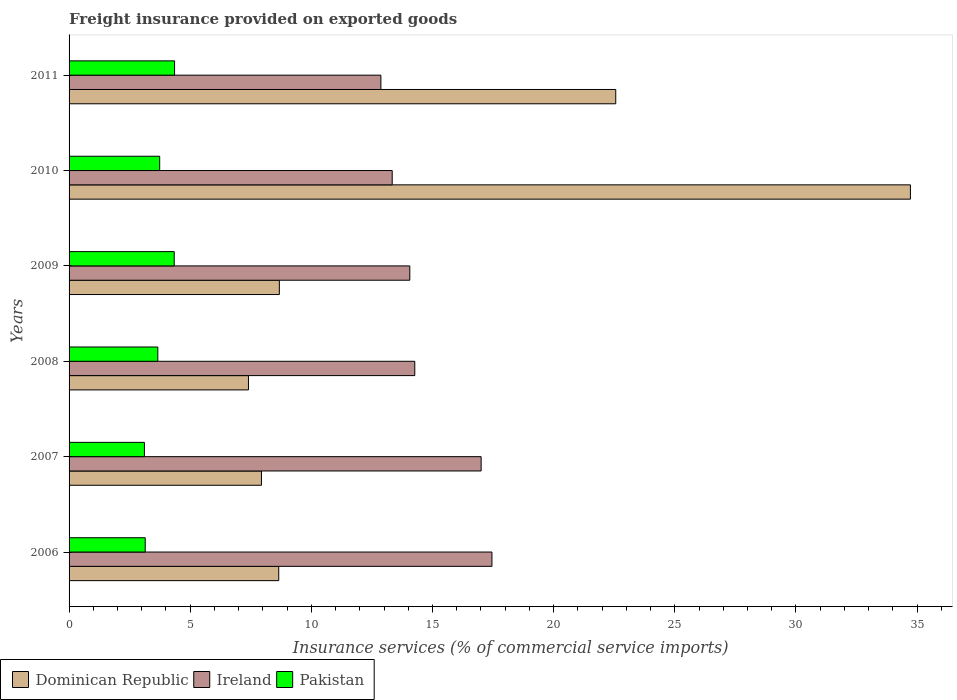How many bars are there on the 6th tick from the top?
Ensure brevity in your answer.  3. What is the label of the 5th group of bars from the top?
Ensure brevity in your answer.  2007. In how many cases, is the number of bars for a given year not equal to the number of legend labels?
Offer a very short reply. 0. What is the freight insurance provided on exported goods in Pakistan in 2006?
Offer a terse response. 3.14. Across all years, what is the maximum freight insurance provided on exported goods in Ireland?
Offer a very short reply. 17.45. Across all years, what is the minimum freight insurance provided on exported goods in Pakistan?
Your answer should be compact. 3.11. In which year was the freight insurance provided on exported goods in Dominican Republic maximum?
Make the answer very short. 2010. In which year was the freight insurance provided on exported goods in Pakistan minimum?
Make the answer very short. 2007. What is the total freight insurance provided on exported goods in Dominican Republic in the graph?
Ensure brevity in your answer.  89.97. What is the difference between the freight insurance provided on exported goods in Dominican Republic in 2009 and that in 2011?
Make the answer very short. -13.89. What is the difference between the freight insurance provided on exported goods in Pakistan in 2006 and the freight insurance provided on exported goods in Dominican Republic in 2009?
Offer a very short reply. -5.54. What is the average freight insurance provided on exported goods in Pakistan per year?
Your response must be concise. 3.73. In the year 2006, what is the difference between the freight insurance provided on exported goods in Pakistan and freight insurance provided on exported goods in Dominican Republic?
Provide a short and direct response. -5.51. In how many years, is the freight insurance provided on exported goods in Pakistan greater than 27 %?
Provide a succinct answer. 0. What is the ratio of the freight insurance provided on exported goods in Ireland in 2008 to that in 2009?
Your response must be concise. 1.01. What is the difference between the highest and the second highest freight insurance provided on exported goods in Pakistan?
Your response must be concise. 0.01. What is the difference between the highest and the lowest freight insurance provided on exported goods in Dominican Republic?
Offer a very short reply. 27.32. In how many years, is the freight insurance provided on exported goods in Pakistan greater than the average freight insurance provided on exported goods in Pakistan taken over all years?
Keep it short and to the point. 3. Is the sum of the freight insurance provided on exported goods in Dominican Republic in 2006 and 2009 greater than the maximum freight insurance provided on exported goods in Ireland across all years?
Provide a short and direct response. No. What does the 3rd bar from the top in 2006 represents?
Keep it short and to the point. Dominican Republic. What does the 2nd bar from the bottom in 2009 represents?
Your response must be concise. Ireland. How many bars are there?
Provide a succinct answer. 18. Are all the bars in the graph horizontal?
Your answer should be very brief. Yes. Are the values on the major ticks of X-axis written in scientific E-notation?
Provide a short and direct response. No. How many legend labels are there?
Your answer should be very brief. 3. How are the legend labels stacked?
Ensure brevity in your answer.  Horizontal. What is the title of the graph?
Your answer should be very brief. Freight insurance provided on exported goods. Does "Europe(all income levels)" appear as one of the legend labels in the graph?
Ensure brevity in your answer.  No. What is the label or title of the X-axis?
Provide a succinct answer. Insurance services (% of commercial service imports). What is the Insurance services (% of commercial service imports) of Dominican Republic in 2006?
Your answer should be very brief. 8.65. What is the Insurance services (% of commercial service imports) of Ireland in 2006?
Give a very brief answer. 17.45. What is the Insurance services (% of commercial service imports) in Pakistan in 2006?
Provide a succinct answer. 3.14. What is the Insurance services (% of commercial service imports) of Dominican Republic in 2007?
Your response must be concise. 7.94. What is the Insurance services (% of commercial service imports) of Ireland in 2007?
Offer a terse response. 17.01. What is the Insurance services (% of commercial service imports) in Pakistan in 2007?
Offer a very short reply. 3.11. What is the Insurance services (% of commercial service imports) in Dominican Republic in 2008?
Offer a terse response. 7.4. What is the Insurance services (% of commercial service imports) in Ireland in 2008?
Make the answer very short. 14.27. What is the Insurance services (% of commercial service imports) of Pakistan in 2008?
Your response must be concise. 3.66. What is the Insurance services (% of commercial service imports) in Dominican Republic in 2009?
Provide a succinct answer. 8.68. What is the Insurance services (% of commercial service imports) in Ireland in 2009?
Your answer should be very brief. 14.06. What is the Insurance services (% of commercial service imports) in Pakistan in 2009?
Offer a very short reply. 4.34. What is the Insurance services (% of commercial service imports) in Dominican Republic in 2010?
Keep it short and to the point. 34.73. What is the Insurance services (% of commercial service imports) of Ireland in 2010?
Give a very brief answer. 13.34. What is the Insurance services (% of commercial service imports) in Pakistan in 2010?
Provide a succinct answer. 3.74. What is the Insurance services (% of commercial service imports) in Dominican Republic in 2011?
Provide a succinct answer. 22.56. What is the Insurance services (% of commercial service imports) in Ireland in 2011?
Provide a succinct answer. 12.87. What is the Insurance services (% of commercial service imports) of Pakistan in 2011?
Your answer should be compact. 4.35. Across all years, what is the maximum Insurance services (% of commercial service imports) of Dominican Republic?
Your answer should be compact. 34.73. Across all years, what is the maximum Insurance services (% of commercial service imports) of Ireland?
Provide a succinct answer. 17.45. Across all years, what is the maximum Insurance services (% of commercial service imports) of Pakistan?
Provide a short and direct response. 4.35. Across all years, what is the minimum Insurance services (% of commercial service imports) of Dominican Republic?
Offer a terse response. 7.4. Across all years, what is the minimum Insurance services (% of commercial service imports) of Ireland?
Ensure brevity in your answer.  12.87. Across all years, what is the minimum Insurance services (% of commercial service imports) of Pakistan?
Your answer should be very brief. 3.11. What is the total Insurance services (% of commercial service imports) of Dominican Republic in the graph?
Keep it short and to the point. 89.97. What is the total Insurance services (% of commercial service imports) of Ireland in the graph?
Make the answer very short. 89. What is the total Insurance services (% of commercial service imports) in Pakistan in the graph?
Your answer should be compact. 22.35. What is the difference between the Insurance services (% of commercial service imports) of Dominican Republic in 2006 and that in 2007?
Your answer should be compact. 0.71. What is the difference between the Insurance services (% of commercial service imports) of Ireland in 2006 and that in 2007?
Offer a terse response. 0.45. What is the difference between the Insurance services (% of commercial service imports) in Pakistan in 2006 and that in 2007?
Offer a terse response. 0.03. What is the difference between the Insurance services (% of commercial service imports) of Dominican Republic in 2006 and that in 2008?
Provide a succinct answer. 1.25. What is the difference between the Insurance services (% of commercial service imports) of Ireland in 2006 and that in 2008?
Your response must be concise. 3.19. What is the difference between the Insurance services (% of commercial service imports) of Pakistan in 2006 and that in 2008?
Your answer should be very brief. -0.52. What is the difference between the Insurance services (% of commercial service imports) in Dominican Republic in 2006 and that in 2009?
Ensure brevity in your answer.  -0.03. What is the difference between the Insurance services (% of commercial service imports) of Ireland in 2006 and that in 2009?
Offer a very short reply. 3.39. What is the difference between the Insurance services (% of commercial service imports) of Pakistan in 2006 and that in 2009?
Your answer should be very brief. -1.2. What is the difference between the Insurance services (% of commercial service imports) in Dominican Republic in 2006 and that in 2010?
Give a very brief answer. -26.07. What is the difference between the Insurance services (% of commercial service imports) of Ireland in 2006 and that in 2010?
Your response must be concise. 4.12. What is the difference between the Insurance services (% of commercial service imports) in Pakistan in 2006 and that in 2010?
Your answer should be compact. -0.6. What is the difference between the Insurance services (% of commercial service imports) in Dominican Republic in 2006 and that in 2011?
Ensure brevity in your answer.  -13.91. What is the difference between the Insurance services (% of commercial service imports) of Ireland in 2006 and that in 2011?
Offer a very short reply. 4.58. What is the difference between the Insurance services (% of commercial service imports) in Pakistan in 2006 and that in 2011?
Give a very brief answer. -1.21. What is the difference between the Insurance services (% of commercial service imports) of Dominican Republic in 2007 and that in 2008?
Your answer should be very brief. 0.54. What is the difference between the Insurance services (% of commercial service imports) in Ireland in 2007 and that in 2008?
Ensure brevity in your answer.  2.74. What is the difference between the Insurance services (% of commercial service imports) in Pakistan in 2007 and that in 2008?
Your answer should be compact. -0.55. What is the difference between the Insurance services (% of commercial service imports) in Dominican Republic in 2007 and that in 2009?
Ensure brevity in your answer.  -0.74. What is the difference between the Insurance services (% of commercial service imports) of Ireland in 2007 and that in 2009?
Your response must be concise. 2.94. What is the difference between the Insurance services (% of commercial service imports) of Pakistan in 2007 and that in 2009?
Provide a succinct answer. -1.23. What is the difference between the Insurance services (% of commercial service imports) of Dominican Republic in 2007 and that in 2010?
Provide a short and direct response. -26.79. What is the difference between the Insurance services (% of commercial service imports) of Ireland in 2007 and that in 2010?
Provide a short and direct response. 3.67. What is the difference between the Insurance services (% of commercial service imports) in Pakistan in 2007 and that in 2010?
Make the answer very short. -0.63. What is the difference between the Insurance services (% of commercial service imports) of Dominican Republic in 2007 and that in 2011?
Offer a terse response. -14.62. What is the difference between the Insurance services (% of commercial service imports) in Ireland in 2007 and that in 2011?
Offer a very short reply. 4.14. What is the difference between the Insurance services (% of commercial service imports) in Pakistan in 2007 and that in 2011?
Make the answer very short. -1.24. What is the difference between the Insurance services (% of commercial service imports) in Dominican Republic in 2008 and that in 2009?
Provide a succinct answer. -1.27. What is the difference between the Insurance services (% of commercial service imports) in Ireland in 2008 and that in 2009?
Provide a short and direct response. 0.21. What is the difference between the Insurance services (% of commercial service imports) in Pakistan in 2008 and that in 2009?
Ensure brevity in your answer.  -0.68. What is the difference between the Insurance services (% of commercial service imports) of Dominican Republic in 2008 and that in 2010?
Keep it short and to the point. -27.32. What is the difference between the Insurance services (% of commercial service imports) in Ireland in 2008 and that in 2010?
Ensure brevity in your answer.  0.93. What is the difference between the Insurance services (% of commercial service imports) in Pakistan in 2008 and that in 2010?
Make the answer very short. -0.08. What is the difference between the Insurance services (% of commercial service imports) of Dominican Republic in 2008 and that in 2011?
Offer a terse response. -15.16. What is the difference between the Insurance services (% of commercial service imports) of Ireland in 2008 and that in 2011?
Your answer should be compact. 1.4. What is the difference between the Insurance services (% of commercial service imports) of Pakistan in 2008 and that in 2011?
Give a very brief answer. -0.69. What is the difference between the Insurance services (% of commercial service imports) in Dominican Republic in 2009 and that in 2010?
Ensure brevity in your answer.  -26.05. What is the difference between the Insurance services (% of commercial service imports) in Ireland in 2009 and that in 2010?
Give a very brief answer. 0.73. What is the difference between the Insurance services (% of commercial service imports) in Pakistan in 2009 and that in 2010?
Give a very brief answer. 0.6. What is the difference between the Insurance services (% of commercial service imports) in Dominican Republic in 2009 and that in 2011?
Ensure brevity in your answer.  -13.89. What is the difference between the Insurance services (% of commercial service imports) in Ireland in 2009 and that in 2011?
Keep it short and to the point. 1.19. What is the difference between the Insurance services (% of commercial service imports) of Pakistan in 2009 and that in 2011?
Make the answer very short. -0.01. What is the difference between the Insurance services (% of commercial service imports) in Dominican Republic in 2010 and that in 2011?
Provide a short and direct response. 12.16. What is the difference between the Insurance services (% of commercial service imports) in Ireland in 2010 and that in 2011?
Give a very brief answer. 0.47. What is the difference between the Insurance services (% of commercial service imports) of Pakistan in 2010 and that in 2011?
Keep it short and to the point. -0.61. What is the difference between the Insurance services (% of commercial service imports) in Dominican Republic in 2006 and the Insurance services (% of commercial service imports) in Ireland in 2007?
Provide a succinct answer. -8.35. What is the difference between the Insurance services (% of commercial service imports) in Dominican Republic in 2006 and the Insurance services (% of commercial service imports) in Pakistan in 2007?
Your answer should be compact. 5.54. What is the difference between the Insurance services (% of commercial service imports) of Ireland in 2006 and the Insurance services (% of commercial service imports) of Pakistan in 2007?
Your response must be concise. 14.34. What is the difference between the Insurance services (% of commercial service imports) in Dominican Republic in 2006 and the Insurance services (% of commercial service imports) in Ireland in 2008?
Provide a short and direct response. -5.61. What is the difference between the Insurance services (% of commercial service imports) of Dominican Republic in 2006 and the Insurance services (% of commercial service imports) of Pakistan in 2008?
Your answer should be compact. 4.99. What is the difference between the Insurance services (% of commercial service imports) of Ireland in 2006 and the Insurance services (% of commercial service imports) of Pakistan in 2008?
Ensure brevity in your answer.  13.79. What is the difference between the Insurance services (% of commercial service imports) of Dominican Republic in 2006 and the Insurance services (% of commercial service imports) of Ireland in 2009?
Your answer should be very brief. -5.41. What is the difference between the Insurance services (% of commercial service imports) of Dominican Republic in 2006 and the Insurance services (% of commercial service imports) of Pakistan in 2009?
Give a very brief answer. 4.31. What is the difference between the Insurance services (% of commercial service imports) in Ireland in 2006 and the Insurance services (% of commercial service imports) in Pakistan in 2009?
Make the answer very short. 13.11. What is the difference between the Insurance services (% of commercial service imports) of Dominican Republic in 2006 and the Insurance services (% of commercial service imports) of Ireland in 2010?
Provide a succinct answer. -4.68. What is the difference between the Insurance services (% of commercial service imports) in Dominican Republic in 2006 and the Insurance services (% of commercial service imports) in Pakistan in 2010?
Offer a terse response. 4.91. What is the difference between the Insurance services (% of commercial service imports) in Ireland in 2006 and the Insurance services (% of commercial service imports) in Pakistan in 2010?
Offer a very short reply. 13.71. What is the difference between the Insurance services (% of commercial service imports) of Dominican Republic in 2006 and the Insurance services (% of commercial service imports) of Ireland in 2011?
Keep it short and to the point. -4.22. What is the difference between the Insurance services (% of commercial service imports) of Dominican Republic in 2006 and the Insurance services (% of commercial service imports) of Pakistan in 2011?
Your answer should be compact. 4.3. What is the difference between the Insurance services (% of commercial service imports) in Ireland in 2006 and the Insurance services (% of commercial service imports) in Pakistan in 2011?
Provide a short and direct response. 13.1. What is the difference between the Insurance services (% of commercial service imports) of Dominican Republic in 2007 and the Insurance services (% of commercial service imports) of Ireland in 2008?
Provide a succinct answer. -6.33. What is the difference between the Insurance services (% of commercial service imports) in Dominican Republic in 2007 and the Insurance services (% of commercial service imports) in Pakistan in 2008?
Your response must be concise. 4.28. What is the difference between the Insurance services (% of commercial service imports) in Ireland in 2007 and the Insurance services (% of commercial service imports) in Pakistan in 2008?
Provide a short and direct response. 13.35. What is the difference between the Insurance services (% of commercial service imports) of Dominican Republic in 2007 and the Insurance services (% of commercial service imports) of Ireland in 2009?
Offer a very short reply. -6.12. What is the difference between the Insurance services (% of commercial service imports) in Dominican Republic in 2007 and the Insurance services (% of commercial service imports) in Pakistan in 2009?
Ensure brevity in your answer.  3.6. What is the difference between the Insurance services (% of commercial service imports) of Ireland in 2007 and the Insurance services (% of commercial service imports) of Pakistan in 2009?
Provide a short and direct response. 12.67. What is the difference between the Insurance services (% of commercial service imports) in Dominican Republic in 2007 and the Insurance services (% of commercial service imports) in Ireland in 2010?
Offer a very short reply. -5.4. What is the difference between the Insurance services (% of commercial service imports) of Dominican Republic in 2007 and the Insurance services (% of commercial service imports) of Pakistan in 2010?
Make the answer very short. 4.2. What is the difference between the Insurance services (% of commercial service imports) of Ireland in 2007 and the Insurance services (% of commercial service imports) of Pakistan in 2010?
Make the answer very short. 13.27. What is the difference between the Insurance services (% of commercial service imports) in Dominican Republic in 2007 and the Insurance services (% of commercial service imports) in Ireland in 2011?
Offer a very short reply. -4.93. What is the difference between the Insurance services (% of commercial service imports) of Dominican Republic in 2007 and the Insurance services (% of commercial service imports) of Pakistan in 2011?
Your answer should be compact. 3.59. What is the difference between the Insurance services (% of commercial service imports) of Ireland in 2007 and the Insurance services (% of commercial service imports) of Pakistan in 2011?
Your answer should be very brief. 12.65. What is the difference between the Insurance services (% of commercial service imports) in Dominican Republic in 2008 and the Insurance services (% of commercial service imports) in Ireland in 2009?
Ensure brevity in your answer.  -6.66. What is the difference between the Insurance services (% of commercial service imports) of Dominican Republic in 2008 and the Insurance services (% of commercial service imports) of Pakistan in 2009?
Your response must be concise. 3.06. What is the difference between the Insurance services (% of commercial service imports) of Ireland in 2008 and the Insurance services (% of commercial service imports) of Pakistan in 2009?
Your response must be concise. 9.93. What is the difference between the Insurance services (% of commercial service imports) of Dominican Republic in 2008 and the Insurance services (% of commercial service imports) of Ireland in 2010?
Offer a terse response. -5.93. What is the difference between the Insurance services (% of commercial service imports) of Dominican Republic in 2008 and the Insurance services (% of commercial service imports) of Pakistan in 2010?
Ensure brevity in your answer.  3.66. What is the difference between the Insurance services (% of commercial service imports) of Ireland in 2008 and the Insurance services (% of commercial service imports) of Pakistan in 2010?
Offer a very short reply. 10.53. What is the difference between the Insurance services (% of commercial service imports) of Dominican Republic in 2008 and the Insurance services (% of commercial service imports) of Ireland in 2011?
Offer a very short reply. -5.47. What is the difference between the Insurance services (% of commercial service imports) of Dominican Republic in 2008 and the Insurance services (% of commercial service imports) of Pakistan in 2011?
Keep it short and to the point. 3.05. What is the difference between the Insurance services (% of commercial service imports) in Ireland in 2008 and the Insurance services (% of commercial service imports) in Pakistan in 2011?
Offer a very short reply. 9.91. What is the difference between the Insurance services (% of commercial service imports) of Dominican Republic in 2009 and the Insurance services (% of commercial service imports) of Ireland in 2010?
Make the answer very short. -4.66. What is the difference between the Insurance services (% of commercial service imports) in Dominican Republic in 2009 and the Insurance services (% of commercial service imports) in Pakistan in 2010?
Offer a terse response. 4.94. What is the difference between the Insurance services (% of commercial service imports) in Ireland in 2009 and the Insurance services (% of commercial service imports) in Pakistan in 2010?
Offer a terse response. 10.32. What is the difference between the Insurance services (% of commercial service imports) of Dominican Republic in 2009 and the Insurance services (% of commercial service imports) of Ireland in 2011?
Provide a short and direct response. -4.19. What is the difference between the Insurance services (% of commercial service imports) of Dominican Republic in 2009 and the Insurance services (% of commercial service imports) of Pakistan in 2011?
Offer a terse response. 4.32. What is the difference between the Insurance services (% of commercial service imports) of Ireland in 2009 and the Insurance services (% of commercial service imports) of Pakistan in 2011?
Provide a succinct answer. 9.71. What is the difference between the Insurance services (% of commercial service imports) in Dominican Republic in 2010 and the Insurance services (% of commercial service imports) in Ireland in 2011?
Provide a succinct answer. 21.86. What is the difference between the Insurance services (% of commercial service imports) in Dominican Republic in 2010 and the Insurance services (% of commercial service imports) in Pakistan in 2011?
Your answer should be compact. 30.37. What is the difference between the Insurance services (% of commercial service imports) in Ireland in 2010 and the Insurance services (% of commercial service imports) in Pakistan in 2011?
Give a very brief answer. 8.98. What is the average Insurance services (% of commercial service imports) of Dominican Republic per year?
Your answer should be compact. 14.99. What is the average Insurance services (% of commercial service imports) in Ireland per year?
Offer a very short reply. 14.83. What is the average Insurance services (% of commercial service imports) of Pakistan per year?
Offer a terse response. 3.73. In the year 2006, what is the difference between the Insurance services (% of commercial service imports) in Dominican Republic and Insurance services (% of commercial service imports) in Ireland?
Give a very brief answer. -8.8. In the year 2006, what is the difference between the Insurance services (% of commercial service imports) in Dominican Republic and Insurance services (% of commercial service imports) in Pakistan?
Give a very brief answer. 5.51. In the year 2006, what is the difference between the Insurance services (% of commercial service imports) of Ireland and Insurance services (% of commercial service imports) of Pakistan?
Give a very brief answer. 14.31. In the year 2007, what is the difference between the Insurance services (% of commercial service imports) of Dominican Republic and Insurance services (% of commercial service imports) of Ireland?
Your answer should be very brief. -9.07. In the year 2007, what is the difference between the Insurance services (% of commercial service imports) of Dominican Republic and Insurance services (% of commercial service imports) of Pakistan?
Offer a terse response. 4.83. In the year 2007, what is the difference between the Insurance services (% of commercial service imports) in Ireland and Insurance services (% of commercial service imports) in Pakistan?
Provide a short and direct response. 13.9. In the year 2008, what is the difference between the Insurance services (% of commercial service imports) in Dominican Republic and Insurance services (% of commercial service imports) in Ireland?
Offer a very short reply. -6.86. In the year 2008, what is the difference between the Insurance services (% of commercial service imports) of Dominican Republic and Insurance services (% of commercial service imports) of Pakistan?
Provide a succinct answer. 3.74. In the year 2008, what is the difference between the Insurance services (% of commercial service imports) of Ireland and Insurance services (% of commercial service imports) of Pakistan?
Ensure brevity in your answer.  10.61. In the year 2009, what is the difference between the Insurance services (% of commercial service imports) in Dominican Republic and Insurance services (% of commercial service imports) in Ireland?
Your answer should be very brief. -5.38. In the year 2009, what is the difference between the Insurance services (% of commercial service imports) in Dominican Republic and Insurance services (% of commercial service imports) in Pakistan?
Your answer should be very brief. 4.34. In the year 2009, what is the difference between the Insurance services (% of commercial service imports) of Ireland and Insurance services (% of commercial service imports) of Pakistan?
Offer a terse response. 9.72. In the year 2010, what is the difference between the Insurance services (% of commercial service imports) in Dominican Republic and Insurance services (% of commercial service imports) in Ireland?
Provide a succinct answer. 21.39. In the year 2010, what is the difference between the Insurance services (% of commercial service imports) of Dominican Republic and Insurance services (% of commercial service imports) of Pakistan?
Provide a succinct answer. 30.99. In the year 2010, what is the difference between the Insurance services (% of commercial service imports) of Ireland and Insurance services (% of commercial service imports) of Pakistan?
Offer a very short reply. 9.6. In the year 2011, what is the difference between the Insurance services (% of commercial service imports) in Dominican Republic and Insurance services (% of commercial service imports) in Ireland?
Give a very brief answer. 9.69. In the year 2011, what is the difference between the Insurance services (% of commercial service imports) of Dominican Republic and Insurance services (% of commercial service imports) of Pakistan?
Offer a very short reply. 18.21. In the year 2011, what is the difference between the Insurance services (% of commercial service imports) in Ireland and Insurance services (% of commercial service imports) in Pakistan?
Ensure brevity in your answer.  8.52. What is the ratio of the Insurance services (% of commercial service imports) in Dominican Republic in 2006 to that in 2007?
Provide a short and direct response. 1.09. What is the ratio of the Insurance services (% of commercial service imports) of Ireland in 2006 to that in 2007?
Keep it short and to the point. 1.03. What is the ratio of the Insurance services (% of commercial service imports) in Pakistan in 2006 to that in 2007?
Keep it short and to the point. 1.01. What is the ratio of the Insurance services (% of commercial service imports) in Dominican Republic in 2006 to that in 2008?
Offer a very short reply. 1.17. What is the ratio of the Insurance services (% of commercial service imports) of Ireland in 2006 to that in 2008?
Your answer should be very brief. 1.22. What is the ratio of the Insurance services (% of commercial service imports) in Pakistan in 2006 to that in 2008?
Provide a short and direct response. 0.86. What is the ratio of the Insurance services (% of commercial service imports) of Dominican Republic in 2006 to that in 2009?
Offer a very short reply. 1. What is the ratio of the Insurance services (% of commercial service imports) in Ireland in 2006 to that in 2009?
Offer a terse response. 1.24. What is the ratio of the Insurance services (% of commercial service imports) of Pakistan in 2006 to that in 2009?
Your response must be concise. 0.72. What is the ratio of the Insurance services (% of commercial service imports) of Dominican Republic in 2006 to that in 2010?
Offer a very short reply. 0.25. What is the ratio of the Insurance services (% of commercial service imports) in Ireland in 2006 to that in 2010?
Your answer should be compact. 1.31. What is the ratio of the Insurance services (% of commercial service imports) of Pakistan in 2006 to that in 2010?
Offer a terse response. 0.84. What is the ratio of the Insurance services (% of commercial service imports) of Dominican Republic in 2006 to that in 2011?
Keep it short and to the point. 0.38. What is the ratio of the Insurance services (% of commercial service imports) of Ireland in 2006 to that in 2011?
Provide a succinct answer. 1.36. What is the ratio of the Insurance services (% of commercial service imports) of Pakistan in 2006 to that in 2011?
Your answer should be very brief. 0.72. What is the ratio of the Insurance services (% of commercial service imports) in Dominican Republic in 2007 to that in 2008?
Provide a succinct answer. 1.07. What is the ratio of the Insurance services (% of commercial service imports) in Ireland in 2007 to that in 2008?
Your answer should be compact. 1.19. What is the ratio of the Insurance services (% of commercial service imports) of Pakistan in 2007 to that in 2008?
Offer a very short reply. 0.85. What is the ratio of the Insurance services (% of commercial service imports) in Dominican Republic in 2007 to that in 2009?
Give a very brief answer. 0.91. What is the ratio of the Insurance services (% of commercial service imports) in Ireland in 2007 to that in 2009?
Offer a terse response. 1.21. What is the ratio of the Insurance services (% of commercial service imports) of Pakistan in 2007 to that in 2009?
Provide a succinct answer. 0.72. What is the ratio of the Insurance services (% of commercial service imports) of Dominican Republic in 2007 to that in 2010?
Ensure brevity in your answer.  0.23. What is the ratio of the Insurance services (% of commercial service imports) in Ireland in 2007 to that in 2010?
Make the answer very short. 1.28. What is the ratio of the Insurance services (% of commercial service imports) in Pakistan in 2007 to that in 2010?
Make the answer very short. 0.83. What is the ratio of the Insurance services (% of commercial service imports) in Dominican Republic in 2007 to that in 2011?
Ensure brevity in your answer.  0.35. What is the ratio of the Insurance services (% of commercial service imports) of Ireland in 2007 to that in 2011?
Keep it short and to the point. 1.32. What is the ratio of the Insurance services (% of commercial service imports) of Pakistan in 2007 to that in 2011?
Provide a succinct answer. 0.71. What is the ratio of the Insurance services (% of commercial service imports) of Dominican Republic in 2008 to that in 2009?
Make the answer very short. 0.85. What is the ratio of the Insurance services (% of commercial service imports) of Ireland in 2008 to that in 2009?
Offer a very short reply. 1.01. What is the ratio of the Insurance services (% of commercial service imports) in Pakistan in 2008 to that in 2009?
Your answer should be very brief. 0.84. What is the ratio of the Insurance services (% of commercial service imports) of Dominican Republic in 2008 to that in 2010?
Ensure brevity in your answer.  0.21. What is the ratio of the Insurance services (% of commercial service imports) in Ireland in 2008 to that in 2010?
Provide a succinct answer. 1.07. What is the ratio of the Insurance services (% of commercial service imports) in Pakistan in 2008 to that in 2010?
Ensure brevity in your answer.  0.98. What is the ratio of the Insurance services (% of commercial service imports) in Dominican Republic in 2008 to that in 2011?
Your response must be concise. 0.33. What is the ratio of the Insurance services (% of commercial service imports) in Ireland in 2008 to that in 2011?
Your answer should be very brief. 1.11. What is the ratio of the Insurance services (% of commercial service imports) of Pakistan in 2008 to that in 2011?
Your answer should be very brief. 0.84. What is the ratio of the Insurance services (% of commercial service imports) of Dominican Republic in 2009 to that in 2010?
Your answer should be compact. 0.25. What is the ratio of the Insurance services (% of commercial service imports) of Ireland in 2009 to that in 2010?
Your response must be concise. 1.05. What is the ratio of the Insurance services (% of commercial service imports) in Pakistan in 2009 to that in 2010?
Your answer should be compact. 1.16. What is the ratio of the Insurance services (% of commercial service imports) in Dominican Republic in 2009 to that in 2011?
Give a very brief answer. 0.38. What is the ratio of the Insurance services (% of commercial service imports) in Ireland in 2009 to that in 2011?
Make the answer very short. 1.09. What is the ratio of the Insurance services (% of commercial service imports) in Pakistan in 2009 to that in 2011?
Give a very brief answer. 1. What is the ratio of the Insurance services (% of commercial service imports) in Dominican Republic in 2010 to that in 2011?
Provide a succinct answer. 1.54. What is the ratio of the Insurance services (% of commercial service imports) in Ireland in 2010 to that in 2011?
Provide a succinct answer. 1.04. What is the ratio of the Insurance services (% of commercial service imports) in Pakistan in 2010 to that in 2011?
Your response must be concise. 0.86. What is the difference between the highest and the second highest Insurance services (% of commercial service imports) in Dominican Republic?
Your answer should be compact. 12.16. What is the difference between the highest and the second highest Insurance services (% of commercial service imports) of Ireland?
Offer a terse response. 0.45. What is the difference between the highest and the second highest Insurance services (% of commercial service imports) in Pakistan?
Offer a very short reply. 0.01. What is the difference between the highest and the lowest Insurance services (% of commercial service imports) of Dominican Republic?
Provide a short and direct response. 27.32. What is the difference between the highest and the lowest Insurance services (% of commercial service imports) of Ireland?
Your answer should be compact. 4.58. What is the difference between the highest and the lowest Insurance services (% of commercial service imports) in Pakistan?
Your answer should be very brief. 1.24. 